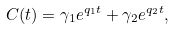Convert formula to latex. <formula><loc_0><loc_0><loc_500><loc_500>C ( t ) = \gamma _ { 1 } e ^ { q _ { 1 } t } + \gamma _ { 2 } e ^ { q _ { 2 } t } ,</formula> 